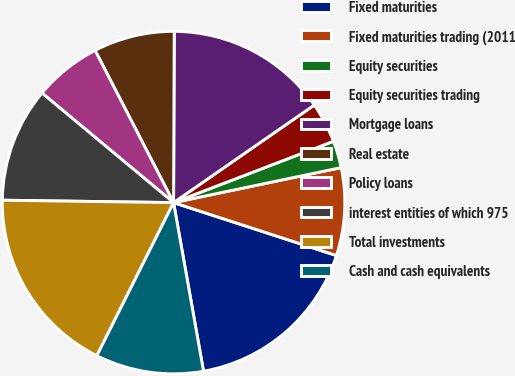<chart> <loc_0><loc_0><loc_500><loc_500><pie_chart><fcel>Fixed maturities<fcel>Fixed maturities trading (2011<fcel>Equity securities<fcel>Equity securities trading<fcel>Mortgage loans<fcel>Real estate<fcel>Policy loans<fcel>interest entities of which 975<fcel>Total investments<fcel>Cash and cash equivalents<nl><fcel>17.2%<fcel>8.28%<fcel>2.55%<fcel>3.82%<fcel>15.29%<fcel>7.64%<fcel>6.37%<fcel>10.83%<fcel>17.83%<fcel>10.19%<nl></chart> 